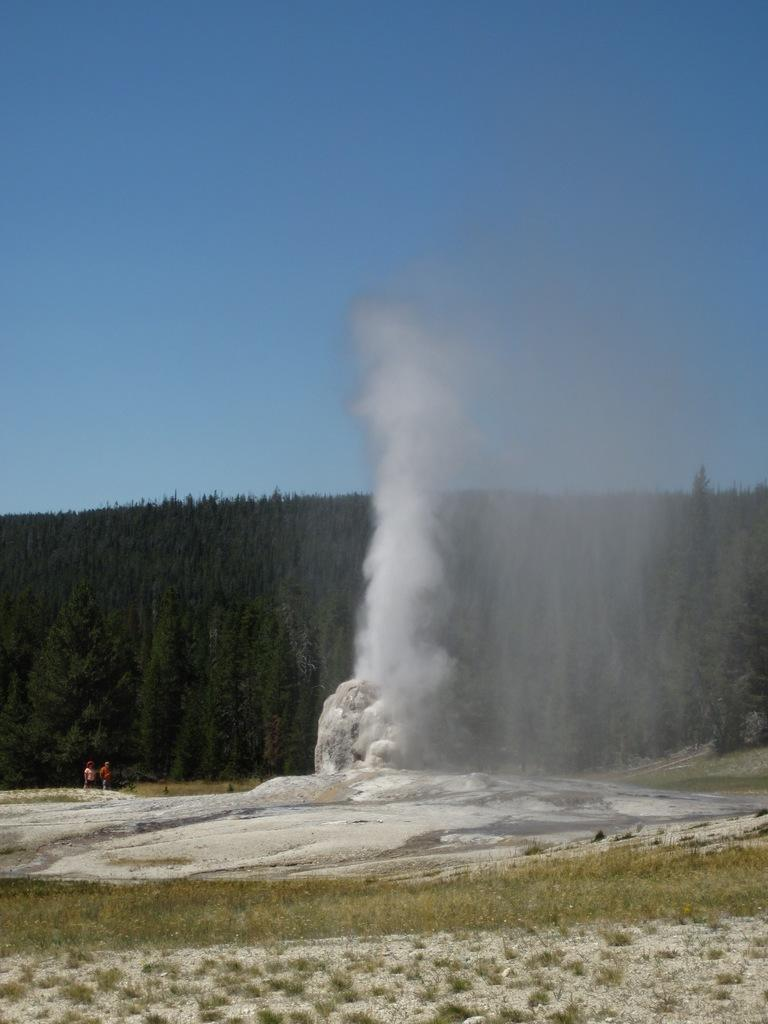What type of vegetation is present in the image? There is grass in the image. What is the other substance visible in the image? There is ice in the image. How many people are in the image? There are two persons in the image. What can be seen in the background of the image? There is smoke, trees, mountains, and the sky visible in the background of the image. What might be the location of the image based on the background? The image is likely taken near mountains. What type of sweater is the person wearing in the image? There is no information about a sweater or any clothing in the image. How many dogs are present in the image? There are no dogs present in the image. 